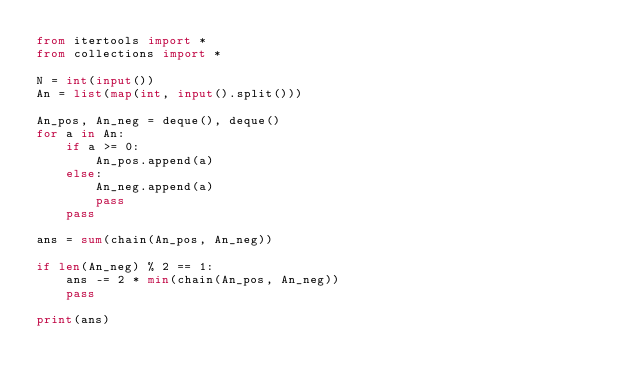Convert code to text. <code><loc_0><loc_0><loc_500><loc_500><_Python_>from itertools import *
from collections import *

N = int(input())
An = list(map(int, input().split()))

An_pos, An_neg = deque(), deque()
for a in An:
    if a >= 0:
        An_pos.append(a)
    else:
        An_neg.append(a)
        pass
    pass

ans = sum(chain(An_pos, An_neg))

if len(An_neg) % 2 == 1:
    ans -= 2 * min(chain(An_pos, An_neg))
    pass

print(ans)
</code> 